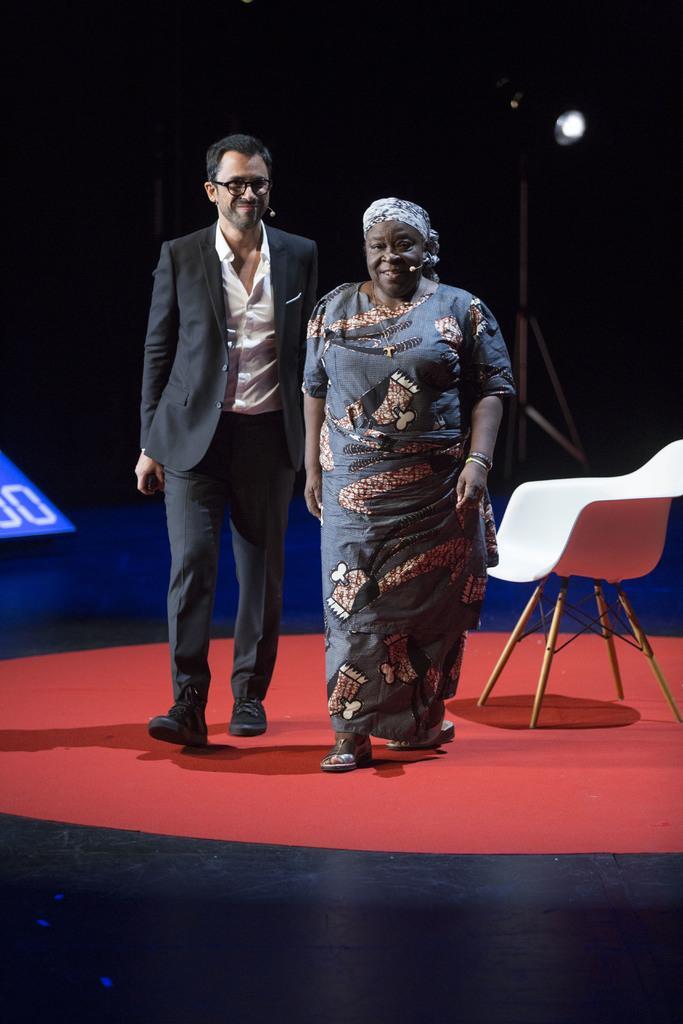Please provide a concise description of this image. Women and men are walking on the stage both are laughing. 